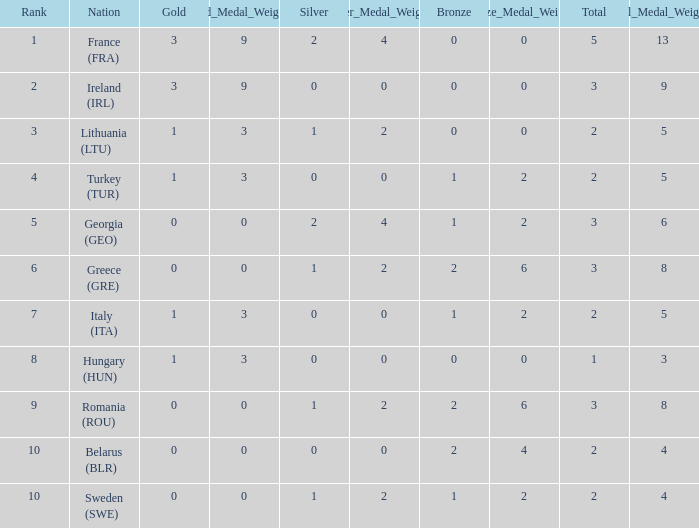Help me parse the entirety of this table. {'header': ['Rank', 'Nation', 'Gold', 'New1_Gold_Medal_Weighted_Points', 'Silver', 'New2_Silver_Medal_Weighted_Points', 'Bronze', 'New3_Bronze_Medal_Weighted_Points', 'Total', 'New4_Total_Medal_Weighted_Points'], 'rows': [['1', 'France (FRA)', '3', '9', '2', '4', '0', '0', '5', '13 '], ['2', 'Ireland (IRL)', '3', '9', '0', '0', '0', '0', '3', '9'], ['3', 'Lithuania (LTU)', '1', '3', '1', '2', '0', '0', '2', '5'], ['4', 'Turkey (TUR)', '1', '3', '0', '0', '1', '2', '2', '5'], ['5', 'Georgia (GEO)', '0', '0', '2', '4', '1', '2', '3', '6'], ['6', 'Greece (GRE)', '0', '0', '1', '2', '2', '6', '3', '8'], ['7', 'Italy (ITA)', '1', '3', '0', '0', '1', '2', '2', '5'], ['8', 'Hungary (HUN)', '1', '3', '0', '0', '0', '0', '1', '3'], ['9', 'Romania (ROU)', '0', '0', '1', '2', '2', '6', '3', '8'], ['10', 'Belarus (BLR)', '0', '0', '0', '0', '2', '4', '2', '4'], ['10', 'Sweden (SWE)', '0', '0', '1', '2', '1', '2', '2', '4']]} What's the total when the gold is less than 0 and silver is less than 1? None. 